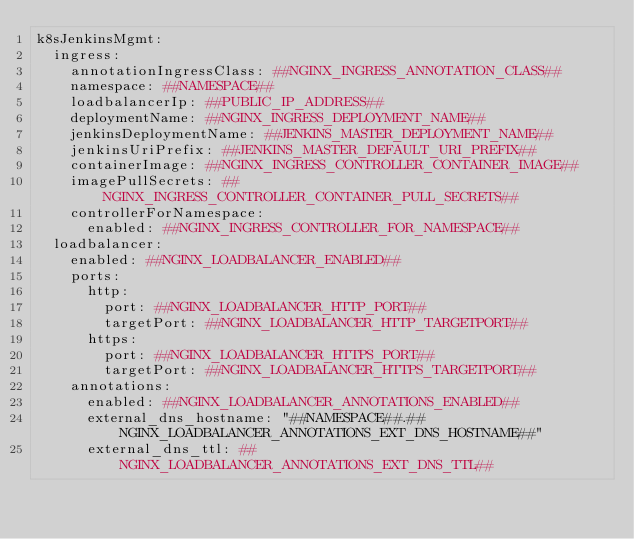Convert code to text. <code><loc_0><loc_0><loc_500><loc_500><_YAML_>k8sJenkinsMgmt:
  ingress:
    annotationIngressClass: ##NGINX_INGRESS_ANNOTATION_CLASS##
    namespace: ##NAMESPACE##
    loadbalancerIp: ##PUBLIC_IP_ADDRESS##
    deploymentName: ##NGINX_INGRESS_DEPLOYMENT_NAME##
    jenkinsDeploymentName: ##JENKINS_MASTER_DEPLOYMENT_NAME##
    jenkinsUriPrefix: ##JENKINS_MASTER_DEFAULT_URI_PREFIX##
    containerImage: ##NGINX_INGRESS_CONTROLLER_CONTAINER_IMAGE##
    imagePullSecrets: ##NGINX_INGRESS_CONTROLLER_CONTAINER_PULL_SECRETS##
    controllerForNamespace:
      enabled: ##NGINX_INGRESS_CONTROLLER_FOR_NAMESPACE##
  loadbalancer:
    enabled: ##NGINX_LOADBALANCER_ENABLED##
    ports:
      http:
        port: ##NGINX_LOADBALANCER_HTTP_PORT##
        targetPort: ##NGINX_LOADBALANCER_HTTP_TARGETPORT##
      https:
        port: ##NGINX_LOADBALANCER_HTTPS_PORT##
        targetPort: ##NGINX_LOADBALANCER_HTTPS_TARGETPORT##
    annotations:
      enabled: ##NGINX_LOADBALANCER_ANNOTATIONS_ENABLED##
      external_dns_hostname: "##NAMESPACE##.##NGINX_LOADBALANCER_ANNOTATIONS_EXT_DNS_HOSTNAME##"
      external_dns_ttl: ##NGINX_LOADBALANCER_ANNOTATIONS_EXT_DNS_TTL##
</code> 